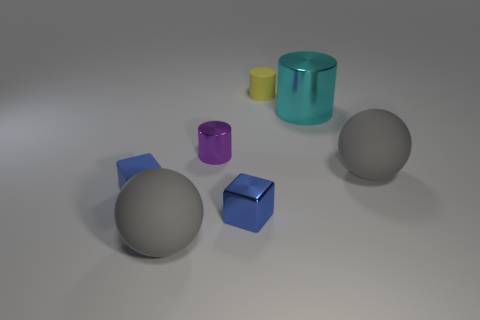What material is the blue object that is the same size as the shiny block? The blue object that matches the size of the shiny block appears to be made of a matte rubber material, characterized by its light-diffusing surface that contrasts with the reflective properties of the nearby shiny block. 